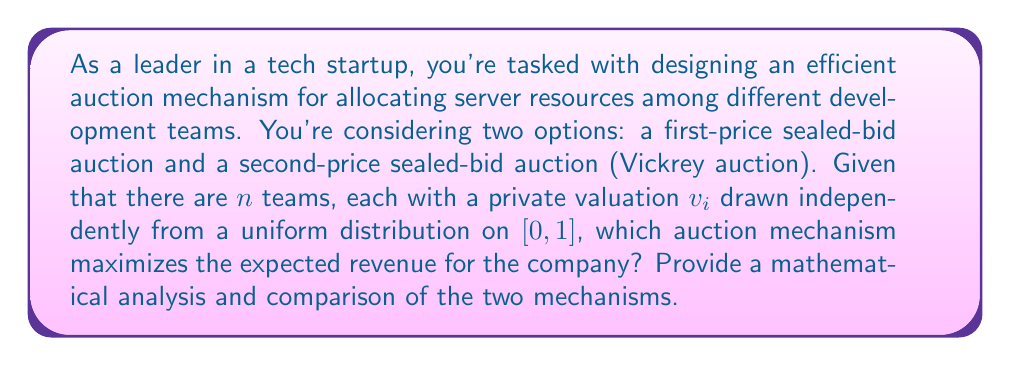Can you solve this math problem? To analyze this problem, we'll use game theory principles to evaluate the efficiency of both auction mechanisms:

1. First-price sealed-bid auction:
In this auction, each bidder submits a sealed bid, and the highest bidder wins, paying their bid amount.

For a bidder with valuation $v$, the optimal bidding strategy is to bid $b(v) = \frac{n-1}{n}v$. This is because:

a) The probability of winning with a bid $b$ is $P(\text{win}) = b^{n-1}$
b) The expected utility is $U(b) = (v-b)b^{n-1}$
c) Maximizing $U(b)$ with respect to $b$ gives the optimal bidding function

The expected revenue for the seller is:

$$E[R_1] = n \int_0^1 b(v) \cdot nv^{n-1} dv = n \int_0^1 \frac{n-1}{n}v \cdot nv^{n-1} dv = \frac{n-1}{n+1}$$

2. Second-price sealed-bid auction (Vickrey auction):
In this auction, each bidder submits a sealed bid, and the highest bidder wins but pays the second-highest bid.

The dominant strategy in a Vickrey auction is to bid truthfully, i.e., $b(v) = v$. This is because:

a) Bidding higher than $v$ risks overpaying
b) Bidding lower than $v$ risks losing a profitable auction

The expected revenue for the seller is:

$$E[R_2] = n(n-1) \int_0^1 v(1-v)v^{n-2} dv = \frac{n-1}{n+1}$$

Comparing the two mechanisms:

$$E[R_1] = E[R_2] = \frac{n-1}{n+1}$$

Both auction mechanisms yield the same expected revenue for the seller. This result is an instance of the Revenue Equivalence Theorem, which states that under certain conditions (including risk-neutral bidders, independent private values, and symmetric bidders), different auction formats yield the same expected revenue.

However, the second-price auction (Vickrey auction) has some advantages:
1. It incentivizes truthful bidding, simplifying the bidding strategy for participants.
2. It's more robust to changes in the number of bidders or their value distributions.
3. It can lead to more efficient allocations, as the item always goes to the bidder who values it most.
Answer: Both the first-price sealed-bid auction and the second-price sealed-bid auction (Vickrey auction) yield the same expected revenue of $\frac{n-1}{n+1}$ for the seller. However, the second-price auction is generally preferred due to its incentive for truthful bidding, robustness, and potential for more efficient resource allocation. 